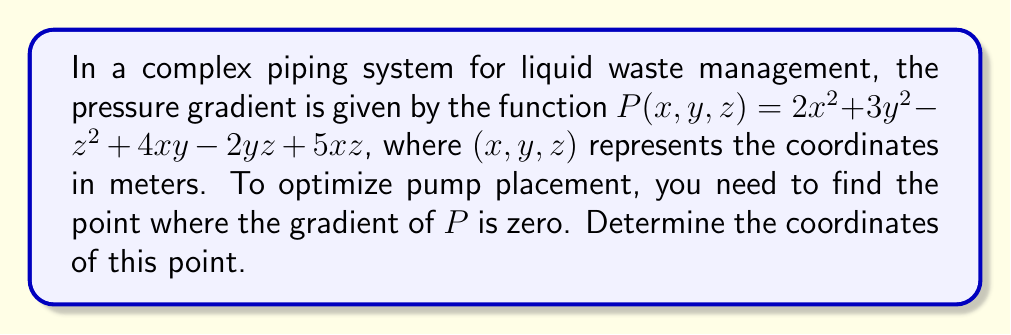Teach me how to tackle this problem. 1. The gradient of $P$ is given by:
   $$\nabla P = \left(\frac{\partial P}{\partial x}, \frac{\partial P}{\partial y}, \frac{\partial P}{\partial z}\right)$$

2. Calculate the partial derivatives:
   $$\frac{\partial P}{\partial x} = 4x + 4y + 5z$$
   $$\frac{\partial P}{\partial y} = 6y + 4x - 2z$$
   $$\frac{\partial P}{\partial z} = -2z + 5x - 2y$$

3. Set each partial derivative to zero:
   $$4x + 4y + 5z = 0 \quad (1)$$
   $$6y + 4x - 2z = 0 \quad (2)$$
   $$-2z + 5x - 2y = 0 \quad (3)$$

4. Solve the system of equations:
   From (3): $z = \frac{5x - 2y}{2} \quad (4)$
   
   Substitute (4) into (1):
   $$4x + 4y + 5(\frac{5x - 2y}{2}) = 0$$
   $$8x + 8y + 25x - 10y = 0$$
   $$33x - 2y = 0 \quad (5)$$
   
   Substitute (4) into (2):
   $$6y + 4x - 2(\frac{5x - 2y}{2}) = 0$$
   $$6y + 4x - 5x + 2y = 0$$
   $$8y - x = 0 \quad (6)$$
   
   From (6): $x = 8y$
   
   Substitute into (5):
   $$33(8y) - 2y = 0$$
   $$264y - 2y = 0$$
   $$262y = 0$$
   $$y = 0$$
   
   Therefore, $x = 8y = 0$
   
   Substitute $x = 0$ and $y = 0$ into (4):
   $$z = \frac{5(0) - 2(0)}{2} = 0$$

5. The point where the gradient is zero is $(0, 0, 0)$.
Answer: $(0, 0, 0)$ 